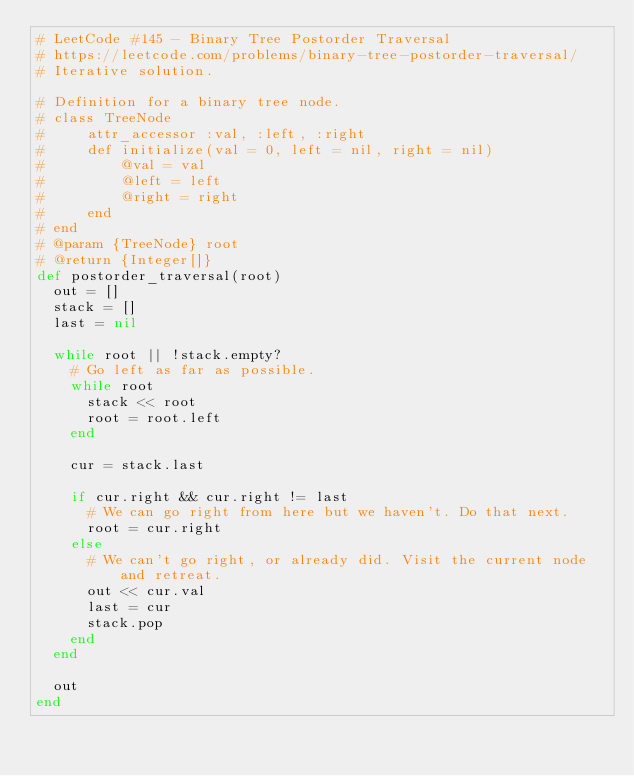<code> <loc_0><loc_0><loc_500><loc_500><_Ruby_># LeetCode #145 - Binary Tree Postorder Traversal
# https://leetcode.com/problems/binary-tree-postorder-traversal/
# Iterative solution.

# Definition for a binary tree node.
# class TreeNode
#     attr_accessor :val, :left, :right
#     def initialize(val = 0, left = nil, right = nil)
#         @val = val
#         @left = left
#         @right = right
#     end
# end
# @param {TreeNode} root
# @return {Integer[]}
def postorder_traversal(root)
  out = []
  stack = []
  last = nil

  while root || !stack.empty?
    # Go left as far as possible.
    while root
      stack << root
      root = root.left
    end

    cur = stack.last

    if cur.right && cur.right != last
      # We can go right from here but we haven't. Do that next.
      root = cur.right
    else
      # We can't go right, or already did. Visit the current node and retreat.
      out << cur.val
      last = cur
      stack.pop
    end
  end

  out
end
</code> 